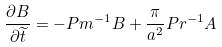Convert formula to latex. <formula><loc_0><loc_0><loc_500><loc_500>\frac { \partial B } { \partial \widetilde { t } } = - P m ^ { - 1 } B + \frac { \pi } { a ^ { 2 } } P r ^ { - 1 } A</formula> 